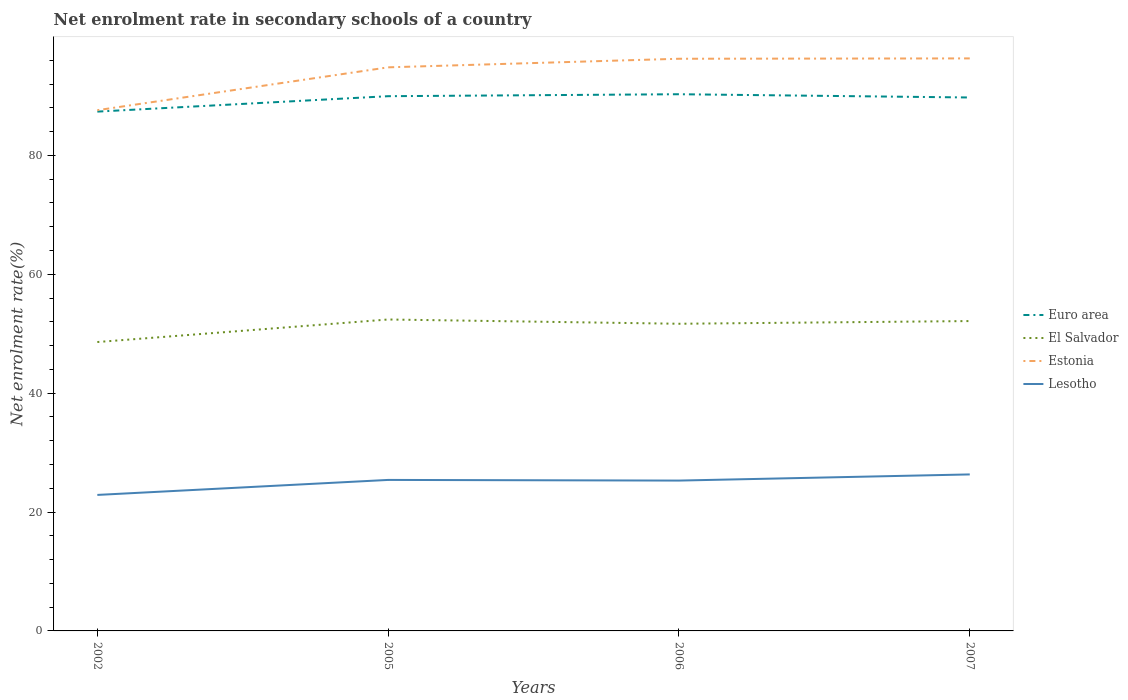How many different coloured lines are there?
Provide a short and direct response. 4. Does the line corresponding to Estonia intersect with the line corresponding to Lesotho?
Provide a short and direct response. No. Is the number of lines equal to the number of legend labels?
Provide a short and direct response. Yes. Across all years, what is the maximum net enrolment rate in secondary schools in Lesotho?
Your answer should be compact. 22.88. In which year was the net enrolment rate in secondary schools in El Salvador maximum?
Offer a very short reply. 2002. What is the total net enrolment rate in secondary schools in El Salvador in the graph?
Ensure brevity in your answer.  0.72. What is the difference between the highest and the second highest net enrolment rate in secondary schools in Estonia?
Your answer should be compact. 8.71. Is the net enrolment rate in secondary schools in El Salvador strictly greater than the net enrolment rate in secondary schools in Euro area over the years?
Offer a terse response. Yes. How many lines are there?
Give a very brief answer. 4. Does the graph contain grids?
Your response must be concise. No. Where does the legend appear in the graph?
Provide a succinct answer. Center right. How many legend labels are there?
Offer a terse response. 4. How are the legend labels stacked?
Give a very brief answer. Vertical. What is the title of the graph?
Your response must be concise. Net enrolment rate in secondary schools of a country. Does "Niger" appear as one of the legend labels in the graph?
Your response must be concise. No. What is the label or title of the X-axis?
Offer a terse response. Years. What is the label or title of the Y-axis?
Offer a terse response. Net enrolment rate(%). What is the Net enrolment rate(%) of Euro area in 2002?
Offer a terse response. 87.36. What is the Net enrolment rate(%) in El Salvador in 2002?
Offer a very short reply. 48.6. What is the Net enrolment rate(%) in Estonia in 2002?
Give a very brief answer. 87.6. What is the Net enrolment rate(%) of Lesotho in 2002?
Provide a short and direct response. 22.88. What is the Net enrolment rate(%) in Euro area in 2005?
Your answer should be very brief. 89.96. What is the Net enrolment rate(%) of El Salvador in 2005?
Keep it short and to the point. 52.39. What is the Net enrolment rate(%) in Estonia in 2005?
Offer a terse response. 94.81. What is the Net enrolment rate(%) in Lesotho in 2005?
Your answer should be compact. 25.4. What is the Net enrolment rate(%) in Euro area in 2006?
Give a very brief answer. 90.29. What is the Net enrolment rate(%) of El Salvador in 2006?
Give a very brief answer. 51.67. What is the Net enrolment rate(%) in Estonia in 2006?
Make the answer very short. 96.26. What is the Net enrolment rate(%) of Lesotho in 2006?
Your answer should be very brief. 25.29. What is the Net enrolment rate(%) of Euro area in 2007?
Offer a terse response. 89.74. What is the Net enrolment rate(%) of El Salvador in 2007?
Give a very brief answer. 52.13. What is the Net enrolment rate(%) of Estonia in 2007?
Provide a succinct answer. 96.32. What is the Net enrolment rate(%) of Lesotho in 2007?
Offer a terse response. 26.33. Across all years, what is the maximum Net enrolment rate(%) of Euro area?
Provide a short and direct response. 90.29. Across all years, what is the maximum Net enrolment rate(%) of El Salvador?
Provide a succinct answer. 52.39. Across all years, what is the maximum Net enrolment rate(%) of Estonia?
Give a very brief answer. 96.32. Across all years, what is the maximum Net enrolment rate(%) of Lesotho?
Give a very brief answer. 26.33. Across all years, what is the minimum Net enrolment rate(%) of Euro area?
Offer a very short reply. 87.36. Across all years, what is the minimum Net enrolment rate(%) of El Salvador?
Your answer should be very brief. 48.6. Across all years, what is the minimum Net enrolment rate(%) in Estonia?
Your answer should be very brief. 87.6. Across all years, what is the minimum Net enrolment rate(%) in Lesotho?
Your response must be concise. 22.88. What is the total Net enrolment rate(%) in Euro area in the graph?
Provide a short and direct response. 357.35. What is the total Net enrolment rate(%) of El Salvador in the graph?
Your answer should be compact. 204.79. What is the total Net enrolment rate(%) in Estonia in the graph?
Make the answer very short. 374.99. What is the total Net enrolment rate(%) in Lesotho in the graph?
Ensure brevity in your answer.  99.9. What is the difference between the Net enrolment rate(%) of Euro area in 2002 and that in 2005?
Offer a very short reply. -2.59. What is the difference between the Net enrolment rate(%) in El Salvador in 2002 and that in 2005?
Your answer should be very brief. -3.79. What is the difference between the Net enrolment rate(%) in Estonia in 2002 and that in 2005?
Provide a succinct answer. -7.21. What is the difference between the Net enrolment rate(%) of Lesotho in 2002 and that in 2005?
Provide a short and direct response. -2.52. What is the difference between the Net enrolment rate(%) of Euro area in 2002 and that in 2006?
Make the answer very short. -2.92. What is the difference between the Net enrolment rate(%) in El Salvador in 2002 and that in 2006?
Your response must be concise. -3.07. What is the difference between the Net enrolment rate(%) in Estonia in 2002 and that in 2006?
Your response must be concise. -8.65. What is the difference between the Net enrolment rate(%) of Lesotho in 2002 and that in 2006?
Your answer should be very brief. -2.41. What is the difference between the Net enrolment rate(%) of Euro area in 2002 and that in 2007?
Your answer should be compact. -2.38. What is the difference between the Net enrolment rate(%) of El Salvador in 2002 and that in 2007?
Ensure brevity in your answer.  -3.53. What is the difference between the Net enrolment rate(%) of Estonia in 2002 and that in 2007?
Ensure brevity in your answer.  -8.71. What is the difference between the Net enrolment rate(%) of Lesotho in 2002 and that in 2007?
Offer a terse response. -3.45. What is the difference between the Net enrolment rate(%) of Euro area in 2005 and that in 2006?
Offer a terse response. -0.33. What is the difference between the Net enrolment rate(%) in El Salvador in 2005 and that in 2006?
Your answer should be compact. 0.72. What is the difference between the Net enrolment rate(%) in Estonia in 2005 and that in 2006?
Provide a succinct answer. -1.44. What is the difference between the Net enrolment rate(%) in Lesotho in 2005 and that in 2006?
Provide a succinct answer. 0.11. What is the difference between the Net enrolment rate(%) in Euro area in 2005 and that in 2007?
Make the answer very short. 0.22. What is the difference between the Net enrolment rate(%) of El Salvador in 2005 and that in 2007?
Offer a very short reply. 0.26. What is the difference between the Net enrolment rate(%) of Estonia in 2005 and that in 2007?
Your response must be concise. -1.5. What is the difference between the Net enrolment rate(%) of Lesotho in 2005 and that in 2007?
Offer a terse response. -0.93. What is the difference between the Net enrolment rate(%) of Euro area in 2006 and that in 2007?
Offer a terse response. 0.55. What is the difference between the Net enrolment rate(%) in El Salvador in 2006 and that in 2007?
Provide a succinct answer. -0.45. What is the difference between the Net enrolment rate(%) in Estonia in 2006 and that in 2007?
Your answer should be compact. -0.06. What is the difference between the Net enrolment rate(%) of Lesotho in 2006 and that in 2007?
Provide a succinct answer. -1.04. What is the difference between the Net enrolment rate(%) in Euro area in 2002 and the Net enrolment rate(%) in El Salvador in 2005?
Offer a very short reply. 34.97. What is the difference between the Net enrolment rate(%) in Euro area in 2002 and the Net enrolment rate(%) in Estonia in 2005?
Your answer should be very brief. -7.45. What is the difference between the Net enrolment rate(%) in Euro area in 2002 and the Net enrolment rate(%) in Lesotho in 2005?
Make the answer very short. 61.96. What is the difference between the Net enrolment rate(%) in El Salvador in 2002 and the Net enrolment rate(%) in Estonia in 2005?
Your response must be concise. -46.21. What is the difference between the Net enrolment rate(%) of El Salvador in 2002 and the Net enrolment rate(%) of Lesotho in 2005?
Your answer should be very brief. 23.2. What is the difference between the Net enrolment rate(%) in Estonia in 2002 and the Net enrolment rate(%) in Lesotho in 2005?
Ensure brevity in your answer.  62.2. What is the difference between the Net enrolment rate(%) of Euro area in 2002 and the Net enrolment rate(%) of El Salvador in 2006?
Make the answer very short. 35.69. What is the difference between the Net enrolment rate(%) of Euro area in 2002 and the Net enrolment rate(%) of Estonia in 2006?
Provide a succinct answer. -8.89. What is the difference between the Net enrolment rate(%) in Euro area in 2002 and the Net enrolment rate(%) in Lesotho in 2006?
Keep it short and to the point. 62.07. What is the difference between the Net enrolment rate(%) of El Salvador in 2002 and the Net enrolment rate(%) of Estonia in 2006?
Give a very brief answer. -47.66. What is the difference between the Net enrolment rate(%) of El Salvador in 2002 and the Net enrolment rate(%) of Lesotho in 2006?
Your response must be concise. 23.31. What is the difference between the Net enrolment rate(%) of Estonia in 2002 and the Net enrolment rate(%) of Lesotho in 2006?
Make the answer very short. 62.31. What is the difference between the Net enrolment rate(%) in Euro area in 2002 and the Net enrolment rate(%) in El Salvador in 2007?
Make the answer very short. 35.24. What is the difference between the Net enrolment rate(%) in Euro area in 2002 and the Net enrolment rate(%) in Estonia in 2007?
Keep it short and to the point. -8.95. What is the difference between the Net enrolment rate(%) in Euro area in 2002 and the Net enrolment rate(%) in Lesotho in 2007?
Give a very brief answer. 61.04. What is the difference between the Net enrolment rate(%) in El Salvador in 2002 and the Net enrolment rate(%) in Estonia in 2007?
Give a very brief answer. -47.72. What is the difference between the Net enrolment rate(%) in El Salvador in 2002 and the Net enrolment rate(%) in Lesotho in 2007?
Offer a very short reply. 22.27. What is the difference between the Net enrolment rate(%) of Estonia in 2002 and the Net enrolment rate(%) of Lesotho in 2007?
Ensure brevity in your answer.  61.27. What is the difference between the Net enrolment rate(%) of Euro area in 2005 and the Net enrolment rate(%) of El Salvador in 2006?
Keep it short and to the point. 38.28. What is the difference between the Net enrolment rate(%) in Euro area in 2005 and the Net enrolment rate(%) in Estonia in 2006?
Your response must be concise. -6.3. What is the difference between the Net enrolment rate(%) of Euro area in 2005 and the Net enrolment rate(%) of Lesotho in 2006?
Your response must be concise. 64.67. What is the difference between the Net enrolment rate(%) of El Salvador in 2005 and the Net enrolment rate(%) of Estonia in 2006?
Provide a succinct answer. -43.86. What is the difference between the Net enrolment rate(%) in El Salvador in 2005 and the Net enrolment rate(%) in Lesotho in 2006?
Your answer should be compact. 27.1. What is the difference between the Net enrolment rate(%) of Estonia in 2005 and the Net enrolment rate(%) of Lesotho in 2006?
Ensure brevity in your answer.  69.52. What is the difference between the Net enrolment rate(%) of Euro area in 2005 and the Net enrolment rate(%) of El Salvador in 2007?
Make the answer very short. 37.83. What is the difference between the Net enrolment rate(%) of Euro area in 2005 and the Net enrolment rate(%) of Estonia in 2007?
Keep it short and to the point. -6.36. What is the difference between the Net enrolment rate(%) in Euro area in 2005 and the Net enrolment rate(%) in Lesotho in 2007?
Provide a short and direct response. 63.63. What is the difference between the Net enrolment rate(%) in El Salvador in 2005 and the Net enrolment rate(%) in Estonia in 2007?
Give a very brief answer. -43.92. What is the difference between the Net enrolment rate(%) in El Salvador in 2005 and the Net enrolment rate(%) in Lesotho in 2007?
Your answer should be compact. 26.06. What is the difference between the Net enrolment rate(%) of Estonia in 2005 and the Net enrolment rate(%) of Lesotho in 2007?
Provide a short and direct response. 68.48. What is the difference between the Net enrolment rate(%) in Euro area in 2006 and the Net enrolment rate(%) in El Salvador in 2007?
Provide a succinct answer. 38.16. What is the difference between the Net enrolment rate(%) in Euro area in 2006 and the Net enrolment rate(%) in Estonia in 2007?
Offer a very short reply. -6.03. What is the difference between the Net enrolment rate(%) in Euro area in 2006 and the Net enrolment rate(%) in Lesotho in 2007?
Your response must be concise. 63.96. What is the difference between the Net enrolment rate(%) in El Salvador in 2006 and the Net enrolment rate(%) in Estonia in 2007?
Your response must be concise. -44.64. What is the difference between the Net enrolment rate(%) of El Salvador in 2006 and the Net enrolment rate(%) of Lesotho in 2007?
Provide a short and direct response. 25.35. What is the difference between the Net enrolment rate(%) of Estonia in 2006 and the Net enrolment rate(%) of Lesotho in 2007?
Keep it short and to the point. 69.93. What is the average Net enrolment rate(%) in Euro area per year?
Make the answer very short. 89.34. What is the average Net enrolment rate(%) of El Salvador per year?
Your response must be concise. 51.2. What is the average Net enrolment rate(%) in Estonia per year?
Give a very brief answer. 93.75. What is the average Net enrolment rate(%) of Lesotho per year?
Offer a very short reply. 24.98. In the year 2002, what is the difference between the Net enrolment rate(%) in Euro area and Net enrolment rate(%) in El Salvador?
Offer a terse response. 38.76. In the year 2002, what is the difference between the Net enrolment rate(%) of Euro area and Net enrolment rate(%) of Estonia?
Make the answer very short. -0.24. In the year 2002, what is the difference between the Net enrolment rate(%) of Euro area and Net enrolment rate(%) of Lesotho?
Offer a terse response. 64.48. In the year 2002, what is the difference between the Net enrolment rate(%) of El Salvador and Net enrolment rate(%) of Estonia?
Your answer should be very brief. -39. In the year 2002, what is the difference between the Net enrolment rate(%) in El Salvador and Net enrolment rate(%) in Lesotho?
Keep it short and to the point. 25.72. In the year 2002, what is the difference between the Net enrolment rate(%) in Estonia and Net enrolment rate(%) in Lesotho?
Your answer should be compact. 64.72. In the year 2005, what is the difference between the Net enrolment rate(%) in Euro area and Net enrolment rate(%) in El Salvador?
Ensure brevity in your answer.  37.57. In the year 2005, what is the difference between the Net enrolment rate(%) of Euro area and Net enrolment rate(%) of Estonia?
Offer a very short reply. -4.86. In the year 2005, what is the difference between the Net enrolment rate(%) of Euro area and Net enrolment rate(%) of Lesotho?
Your response must be concise. 64.56. In the year 2005, what is the difference between the Net enrolment rate(%) of El Salvador and Net enrolment rate(%) of Estonia?
Your answer should be very brief. -42.42. In the year 2005, what is the difference between the Net enrolment rate(%) of El Salvador and Net enrolment rate(%) of Lesotho?
Offer a terse response. 26.99. In the year 2005, what is the difference between the Net enrolment rate(%) of Estonia and Net enrolment rate(%) of Lesotho?
Give a very brief answer. 69.41. In the year 2006, what is the difference between the Net enrolment rate(%) in Euro area and Net enrolment rate(%) in El Salvador?
Make the answer very short. 38.61. In the year 2006, what is the difference between the Net enrolment rate(%) in Euro area and Net enrolment rate(%) in Estonia?
Give a very brief answer. -5.97. In the year 2006, what is the difference between the Net enrolment rate(%) of Euro area and Net enrolment rate(%) of Lesotho?
Give a very brief answer. 64.99. In the year 2006, what is the difference between the Net enrolment rate(%) of El Salvador and Net enrolment rate(%) of Estonia?
Provide a succinct answer. -44.58. In the year 2006, what is the difference between the Net enrolment rate(%) in El Salvador and Net enrolment rate(%) in Lesotho?
Your response must be concise. 26.38. In the year 2006, what is the difference between the Net enrolment rate(%) of Estonia and Net enrolment rate(%) of Lesotho?
Provide a short and direct response. 70.96. In the year 2007, what is the difference between the Net enrolment rate(%) in Euro area and Net enrolment rate(%) in El Salvador?
Give a very brief answer. 37.61. In the year 2007, what is the difference between the Net enrolment rate(%) in Euro area and Net enrolment rate(%) in Estonia?
Ensure brevity in your answer.  -6.58. In the year 2007, what is the difference between the Net enrolment rate(%) in Euro area and Net enrolment rate(%) in Lesotho?
Your answer should be compact. 63.41. In the year 2007, what is the difference between the Net enrolment rate(%) in El Salvador and Net enrolment rate(%) in Estonia?
Offer a very short reply. -44.19. In the year 2007, what is the difference between the Net enrolment rate(%) of El Salvador and Net enrolment rate(%) of Lesotho?
Offer a very short reply. 25.8. In the year 2007, what is the difference between the Net enrolment rate(%) in Estonia and Net enrolment rate(%) in Lesotho?
Your response must be concise. 69.99. What is the ratio of the Net enrolment rate(%) of Euro area in 2002 to that in 2005?
Your answer should be compact. 0.97. What is the ratio of the Net enrolment rate(%) of El Salvador in 2002 to that in 2005?
Your answer should be very brief. 0.93. What is the ratio of the Net enrolment rate(%) of Estonia in 2002 to that in 2005?
Offer a very short reply. 0.92. What is the ratio of the Net enrolment rate(%) of Lesotho in 2002 to that in 2005?
Offer a very short reply. 0.9. What is the ratio of the Net enrolment rate(%) of Euro area in 2002 to that in 2006?
Provide a succinct answer. 0.97. What is the ratio of the Net enrolment rate(%) in El Salvador in 2002 to that in 2006?
Your answer should be compact. 0.94. What is the ratio of the Net enrolment rate(%) of Estonia in 2002 to that in 2006?
Provide a short and direct response. 0.91. What is the ratio of the Net enrolment rate(%) of Lesotho in 2002 to that in 2006?
Provide a succinct answer. 0.9. What is the ratio of the Net enrolment rate(%) in Euro area in 2002 to that in 2007?
Offer a very short reply. 0.97. What is the ratio of the Net enrolment rate(%) of El Salvador in 2002 to that in 2007?
Your answer should be compact. 0.93. What is the ratio of the Net enrolment rate(%) of Estonia in 2002 to that in 2007?
Give a very brief answer. 0.91. What is the ratio of the Net enrolment rate(%) in Lesotho in 2002 to that in 2007?
Keep it short and to the point. 0.87. What is the ratio of the Net enrolment rate(%) of Euro area in 2005 to that in 2006?
Provide a short and direct response. 1. What is the ratio of the Net enrolment rate(%) in El Salvador in 2005 to that in 2006?
Offer a terse response. 1.01. What is the ratio of the Net enrolment rate(%) in Estonia in 2005 to that in 2006?
Your answer should be very brief. 0.98. What is the ratio of the Net enrolment rate(%) in Lesotho in 2005 to that in 2006?
Ensure brevity in your answer.  1. What is the ratio of the Net enrolment rate(%) in El Salvador in 2005 to that in 2007?
Ensure brevity in your answer.  1.01. What is the ratio of the Net enrolment rate(%) in Estonia in 2005 to that in 2007?
Provide a short and direct response. 0.98. What is the ratio of the Net enrolment rate(%) in Lesotho in 2005 to that in 2007?
Offer a very short reply. 0.96. What is the ratio of the Net enrolment rate(%) of El Salvador in 2006 to that in 2007?
Your answer should be compact. 0.99. What is the ratio of the Net enrolment rate(%) of Estonia in 2006 to that in 2007?
Your response must be concise. 1. What is the ratio of the Net enrolment rate(%) of Lesotho in 2006 to that in 2007?
Provide a succinct answer. 0.96. What is the difference between the highest and the second highest Net enrolment rate(%) in Euro area?
Give a very brief answer. 0.33. What is the difference between the highest and the second highest Net enrolment rate(%) in El Salvador?
Your answer should be very brief. 0.26. What is the difference between the highest and the second highest Net enrolment rate(%) of Estonia?
Provide a short and direct response. 0.06. What is the difference between the highest and the second highest Net enrolment rate(%) of Lesotho?
Provide a succinct answer. 0.93. What is the difference between the highest and the lowest Net enrolment rate(%) in Euro area?
Your response must be concise. 2.92. What is the difference between the highest and the lowest Net enrolment rate(%) in El Salvador?
Make the answer very short. 3.79. What is the difference between the highest and the lowest Net enrolment rate(%) in Estonia?
Make the answer very short. 8.71. What is the difference between the highest and the lowest Net enrolment rate(%) in Lesotho?
Offer a very short reply. 3.45. 